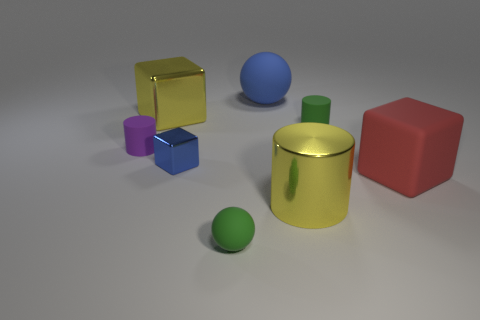What shape is the small blue object?
Your answer should be compact. Cube. There is a metallic object behind the small object that is to the left of the yellow cube; what is its size?
Make the answer very short. Large. Is the number of big red blocks that are left of the large metallic cube the same as the number of small purple matte cylinders on the right side of the large blue ball?
Keep it short and to the point. Yes. What is the material of the object that is to the right of the large ball and behind the tiny blue metallic block?
Give a very brief answer. Rubber. There is a blue block; is its size the same as the metal object to the right of the large blue object?
Give a very brief answer. No. How many other objects are there of the same color as the big metal cylinder?
Keep it short and to the point. 1. Is the number of cubes behind the large matte block greater than the number of red matte blocks?
Your answer should be very brief. Yes. What is the color of the big metal block that is behind the rubber cylinder that is to the left of the yellow shiny thing to the right of the large yellow metallic cube?
Make the answer very short. Yellow. Is the large sphere made of the same material as the tiny blue block?
Ensure brevity in your answer.  No. Is there a sphere that has the same size as the red rubber block?
Your answer should be compact. Yes. 